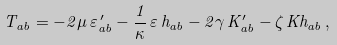Convert formula to latex. <formula><loc_0><loc_0><loc_500><loc_500>T _ { a b } = - 2 \mu \, { \varepsilon } ^ { \, \prime } _ { a b } - \frac { 1 } { \kappa } \, \varepsilon \, h _ { a b } - 2 \gamma \, { K } ^ { \prime } _ { a b } - \zeta \, K h _ { a b } \, ,</formula> 